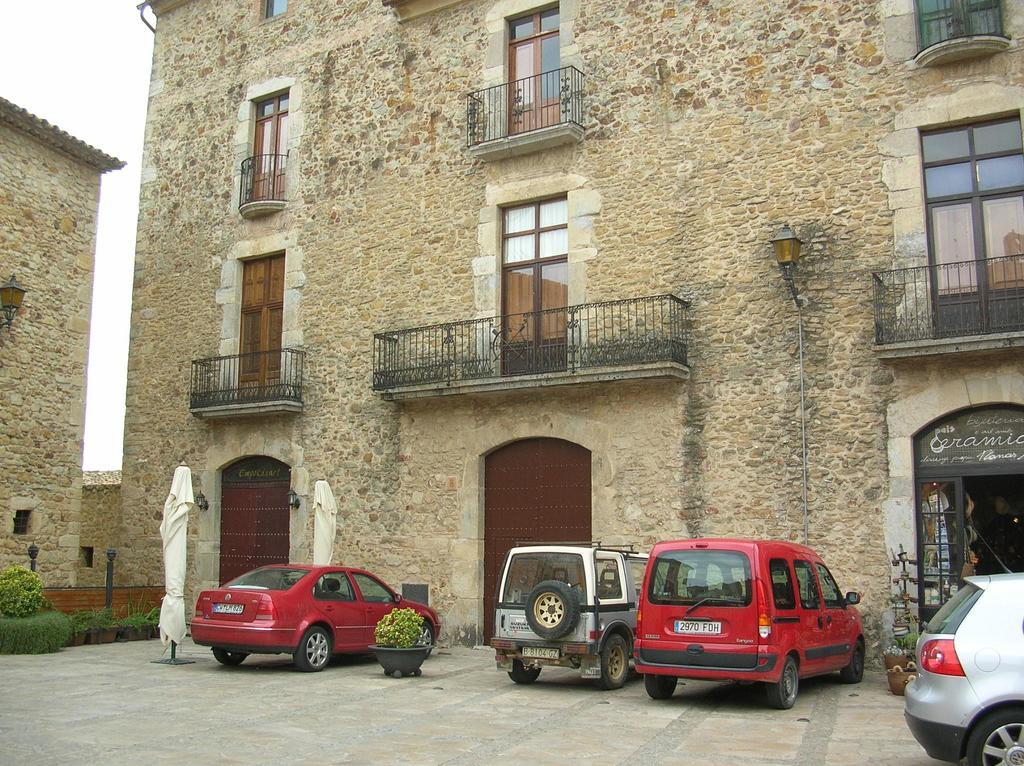What types of objects can be seen in the image? There are vehicles in the image. What is located in front of the vehicles? There is a building in front of the vehicles. What other elements are present in the image? There are plants in the image. Can you describe the building in the left corner of the image? There is a building in the left corner of the image. Who is the creator of the plants in the image? There is no information about the creator of the plants in the image; they are simply present in the scene. 